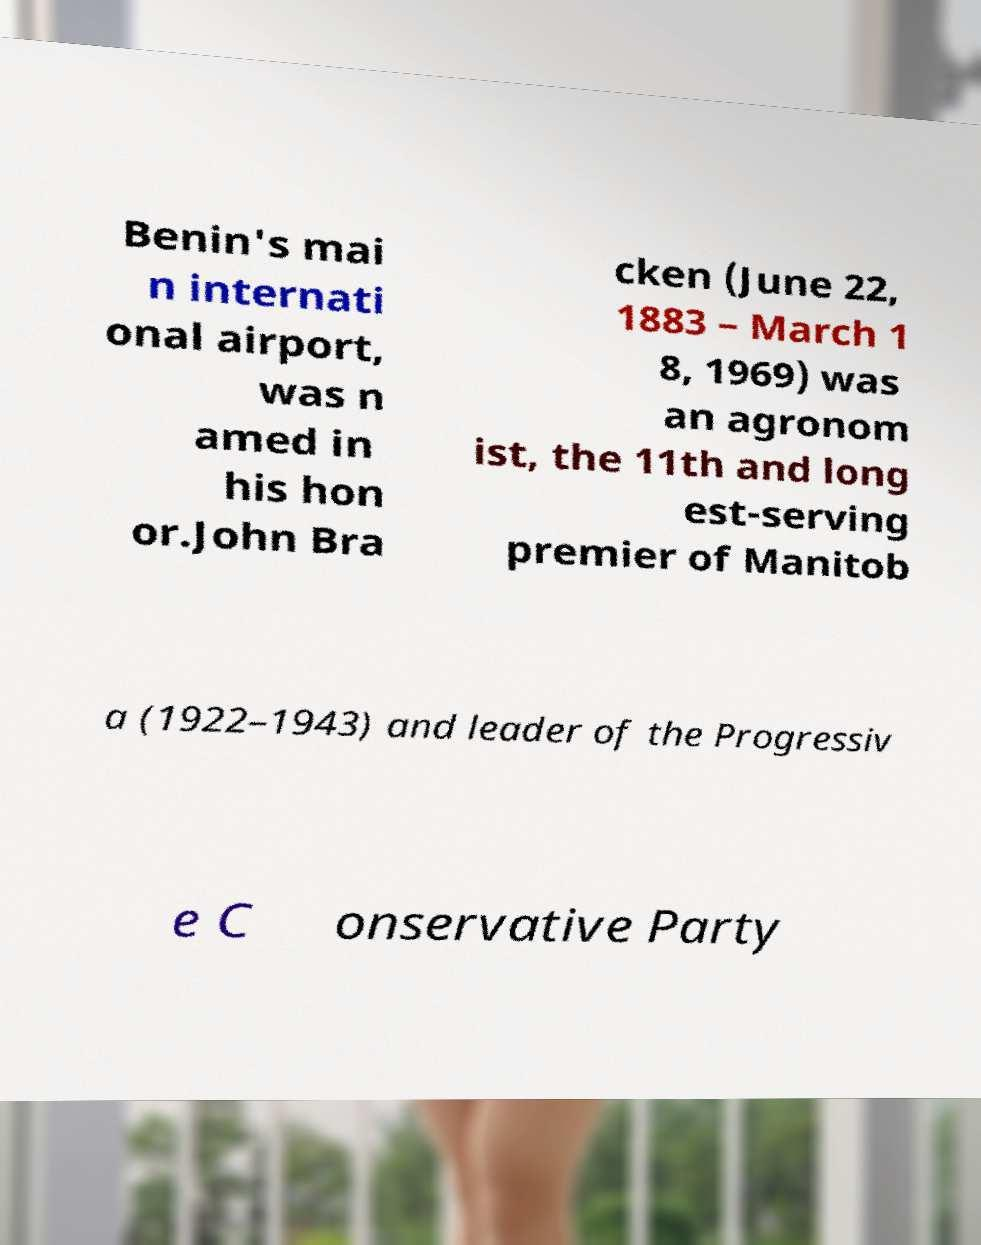Can you accurately transcribe the text from the provided image for me? Benin's mai n internati onal airport, was n amed in his hon or.John Bra cken (June 22, 1883 – March 1 8, 1969) was an agronom ist, the 11th and long est-serving premier of Manitob a (1922–1943) and leader of the Progressiv e C onservative Party 